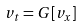<formula> <loc_0><loc_0><loc_500><loc_500>v _ { t } = G [ v _ { x } ]</formula> 